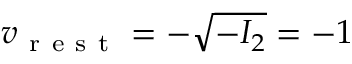<formula> <loc_0><loc_0><loc_500><loc_500>v _ { r e s t } = - \sqrt { - I _ { 2 } } = - 1</formula> 